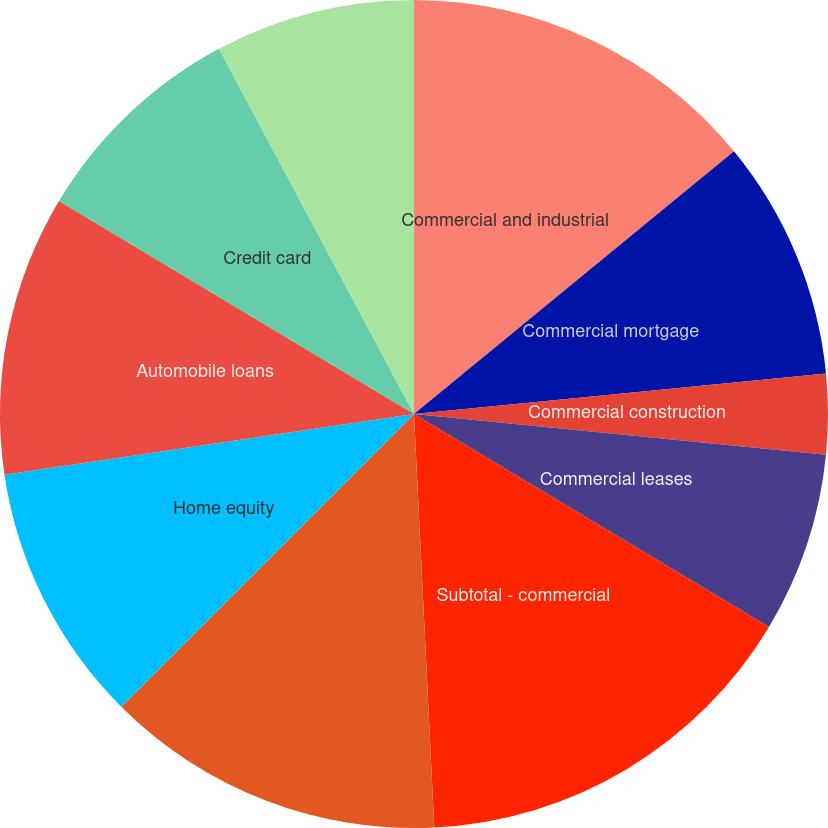Convert chart to OTSL. <chart><loc_0><loc_0><loc_500><loc_500><pie_chart><fcel>Commercial and industrial<fcel>Commercial mortgage<fcel>Commercial construction<fcel>Commercial leases<fcel>Subtotal - commercial<fcel>Residential mortgage loans<fcel>Home equity<fcel>Automobile loans<fcel>Credit card<fcel>Other consumer loans/leases<nl><fcel>14.06%<fcel>9.38%<fcel>3.13%<fcel>7.03%<fcel>15.62%<fcel>13.28%<fcel>10.16%<fcel>10.94%<fcel>8.59%<fcel>7.81%<nl></chart> 